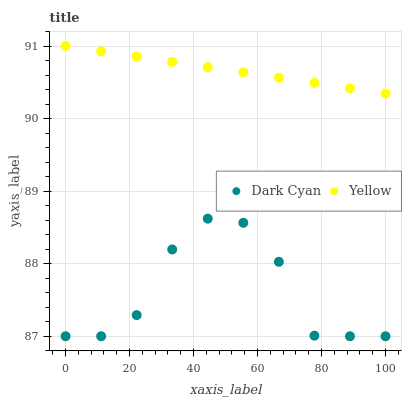Does Dark Cyan have the minimum area under the curve?
Answer yes or no. Yes. Does Yellow have the maximum area under the curve?
Answer yes or no. Yes. Does Yellow have the minimum area under the curve?
Answer yes or no. No. Is Yellow the smoothest?
Answer yes or no. Yes. Is Dark Cyan the roughest?
Answer yes or no. Yes. Is Yellow the roughest?
Answer yes or no. No. Does Dark Cyan have the lowest value?
Answer yes or no. Yes. Does Yellow have the lowest value?
Answer yes or no. No. Does Yellow have the highest value?
Answer yes or no. Yes. Is Dark Cyan less than Yellow?
Answer yes or no. Yes. Is Yellow greater than Dark Cyan?
Answer yes or no. Yes. Does Dark Cyan intersect Yellow?
Answer yes or no. No. 